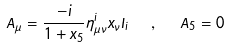<formula> <loc_0><loc_0><loc_500><loc_500>A _ { \mu } = \frac { - i } { 1 + x _ { 5 } } \eta _ { \mu \nu } ^ { i } x _ { \nu } I _ { i } \ \ , \ \ A _ { 5 } = 0</formula> 